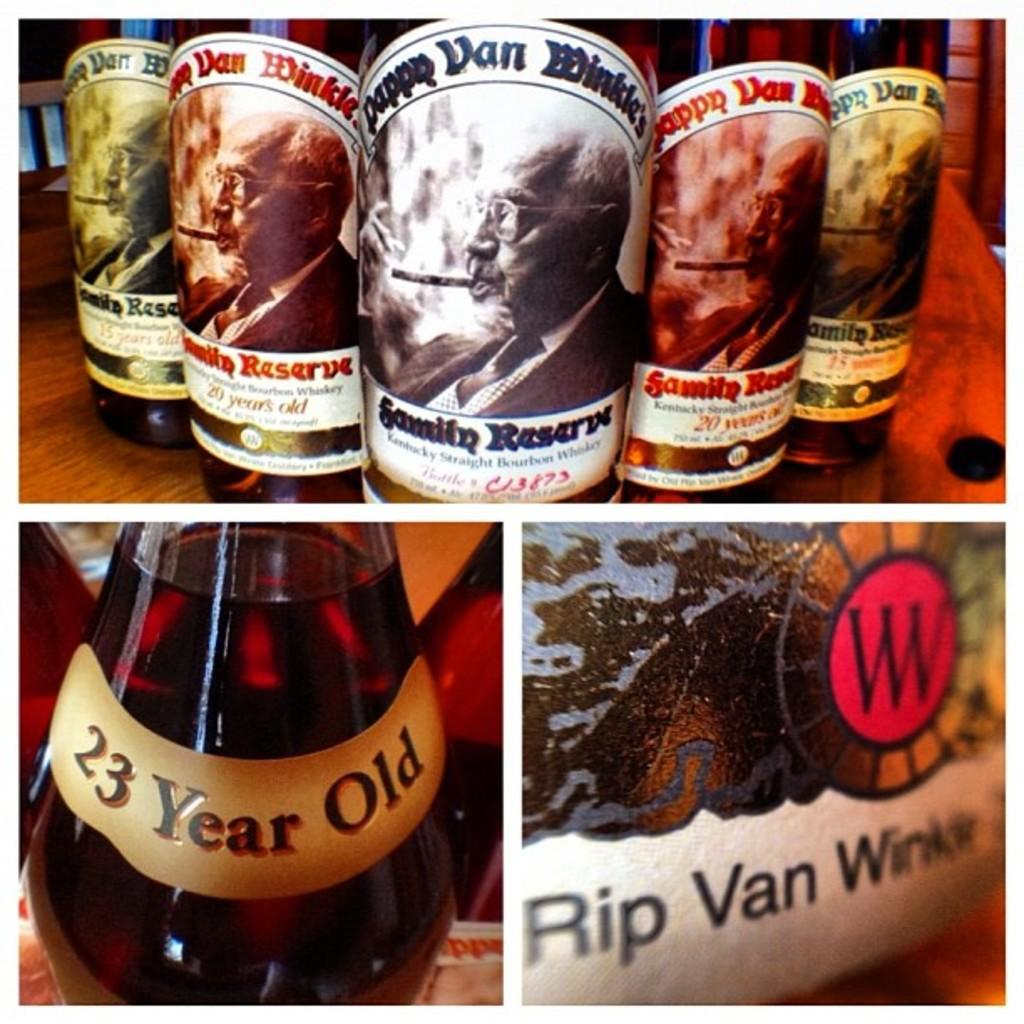<image>
Relay a brief, clear account of the picture shown. Collage of photos with one showing a 23 year old bottle. 